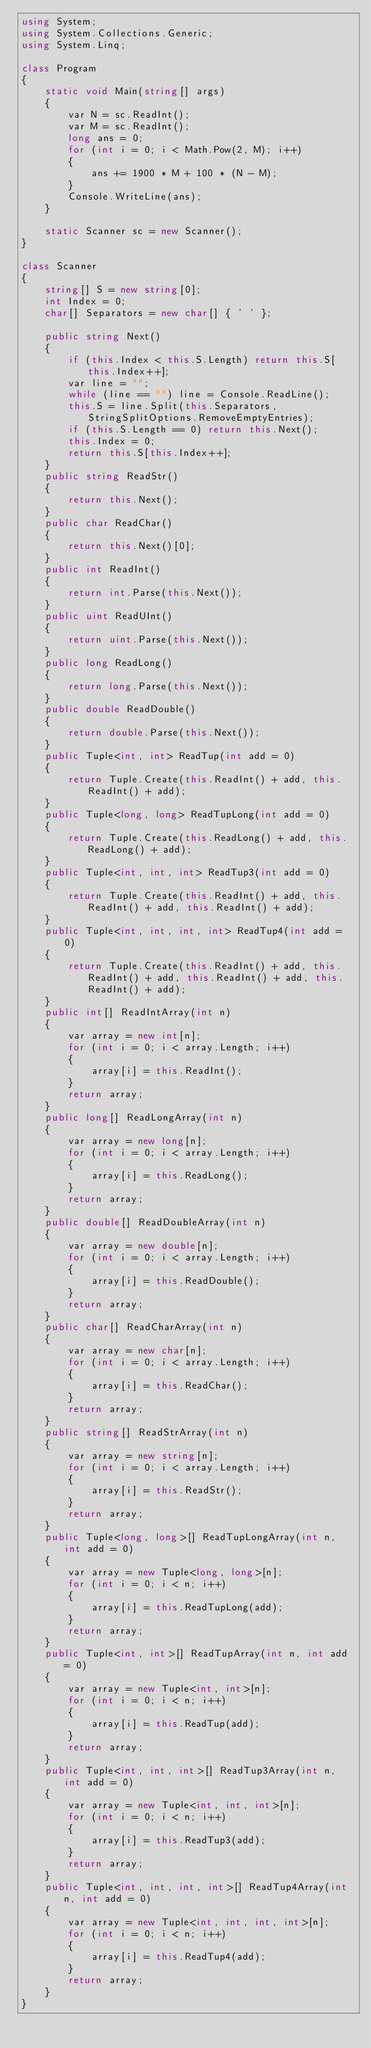Convert code to text. <code><loc_0><loc_0><loc_500><loc_500><_C#_>using System;
using System.Collections.Generic;
using System.Linq;

class Program
{
    static void Main(string[] args)
    {
        var N = sc.ReadInt();
        var M = sc.ReadInt();
        long ans = 0;
        for (int i = 0; i < Math.Pow(2, M); i++)
        {
            ans += 1900 * M + 100 * (N - M);
        }
        Console.WriteLine(ans);
    }

    static Scanner sc = new Scanner();
}

class Scanner
{
    string[] S = new string[0];
    int Index = 0;
    char[] Separators = new char[] { ' ' };

    public string Next()
    {
        if (this.Index < this.S.Length) return this.S[this.Index++];
        var line = "";
        while (line == "") line = Console.ReadLine();
        this.S = line.Split(this.Separators, StringSplitOptions.RemoveEmptyEntries);
        if (this.S.Length == 0) return this.Next();
        this.Index = 0;
        return this.S[this.Index++];
    }
    public string ReadStr()
    {
        return this.Next();
    }
    public char ReadChar()
    {
        return this.Next()[0];
    }
    public int ReadInt()
    {
        return int.Parse(this.Next());
    }
    public uint ReadUInt()
    {
        return uint.Parse(this.Next());
    }
    public long ReadLong()
    {
        return long.Parse(this.Next());
    }
    public double ReadDouble()
    {
        return double.Parse(this.Next());
    }
    public Tuple<int, int> ReadTup(int add = 0)
    {
        return Tuple.Create(this.ReadInt() + add, this.ReadInt() + add);
    }
    public Tuple<long, long> ReadTupLong(int add = 0)
    {
        return Tuple.Create(this.ReadLong() + add, this.ReadLong() + add);
    }
    public Tuple<int, int, int> ReadTup3(int add = 0)
    {
        return Tuple.Create(this.ReadInt() + add, this.ReadInt() + add, this.ReadInt() + add);
    }
    public Tuple<int, int, int, int> ReadTup4(int add = 0)
    {
        return Tuple.Create(this.ReadInt() + add, this.ReadInt() + add, this.ReadInt() + add, this.ReadInt() + add);
    }
    public int[] ReadIntArray(int n)
    {
        var array = new int[n];
        for (int i = 0; i < array.Length; i++)
        {
            array[i] = this.ReadInt();
        }
        return array;
    }
    public long[] ReadLongArray(int n)
    {
        var array = new long[n];
        for (int i = 0; i < array.Length; i++)
        {
            array[i] = this.ReadLong();
        }
        return array;
    }
    public double[] ReadDoubleArray(int n)
    {
        var array = new double[n];
        for (int i = 0; i < array.Length; i++)
        {
            array[i] = this.ReadDouble();
        }
        return array;
    }
    public char[] ReadCharArray(int n)
    {
        var array = new char[n];
        for (int i = 0; i < array.Length; i++)
        {
            array[i] = this.ReadChar();
        }
        return array;
    }
    public string[] ReadStrArray(int n)
    {
        var array = new string[n];
        for (int i = 0; i < array.Length; i++)
        {
            array[i] = this.ReadStr();
        }
        return array;
    }
    public Tuple<long, long>[] ReadTupLongArray(int n, int add = 0)
    {
        var array = new Tuple<long, long>[n];
        for (int i = 0; i < n; i++)
        {
            array[i] = this.ReadTupLong(add);
        }
        return array;
    }
    public Tuple<int, int>[] ReadTupArray(int n, int add = 0)
    {
        var array = new Tuple<int, int>[n];
        for (int i = 0; i < n; i++)
        {
            array[i] = this.ReadTup(add);
        }
        return array;
    }
    public Tuple<int, int, int>[] ReadTup3Array(int n, int add = 0)
    {
        var array = new Tuple<int, int, int>[n];
        for (int i = 0; i < n; i++)
        {
            array[i] = this.ReadTup3(add);
        }
        return array;
    }
    public Tuple<int, int, int, int>[] ReadTup4Array(int n, int add = 0)
    {
        var array = new Tuple<int, int, int, int>[n];
        for (int i = 0; i < n; i++)
        {
            array[i] = this.ReadTup4(add);
        }
        return array;
    }
}
</code> 